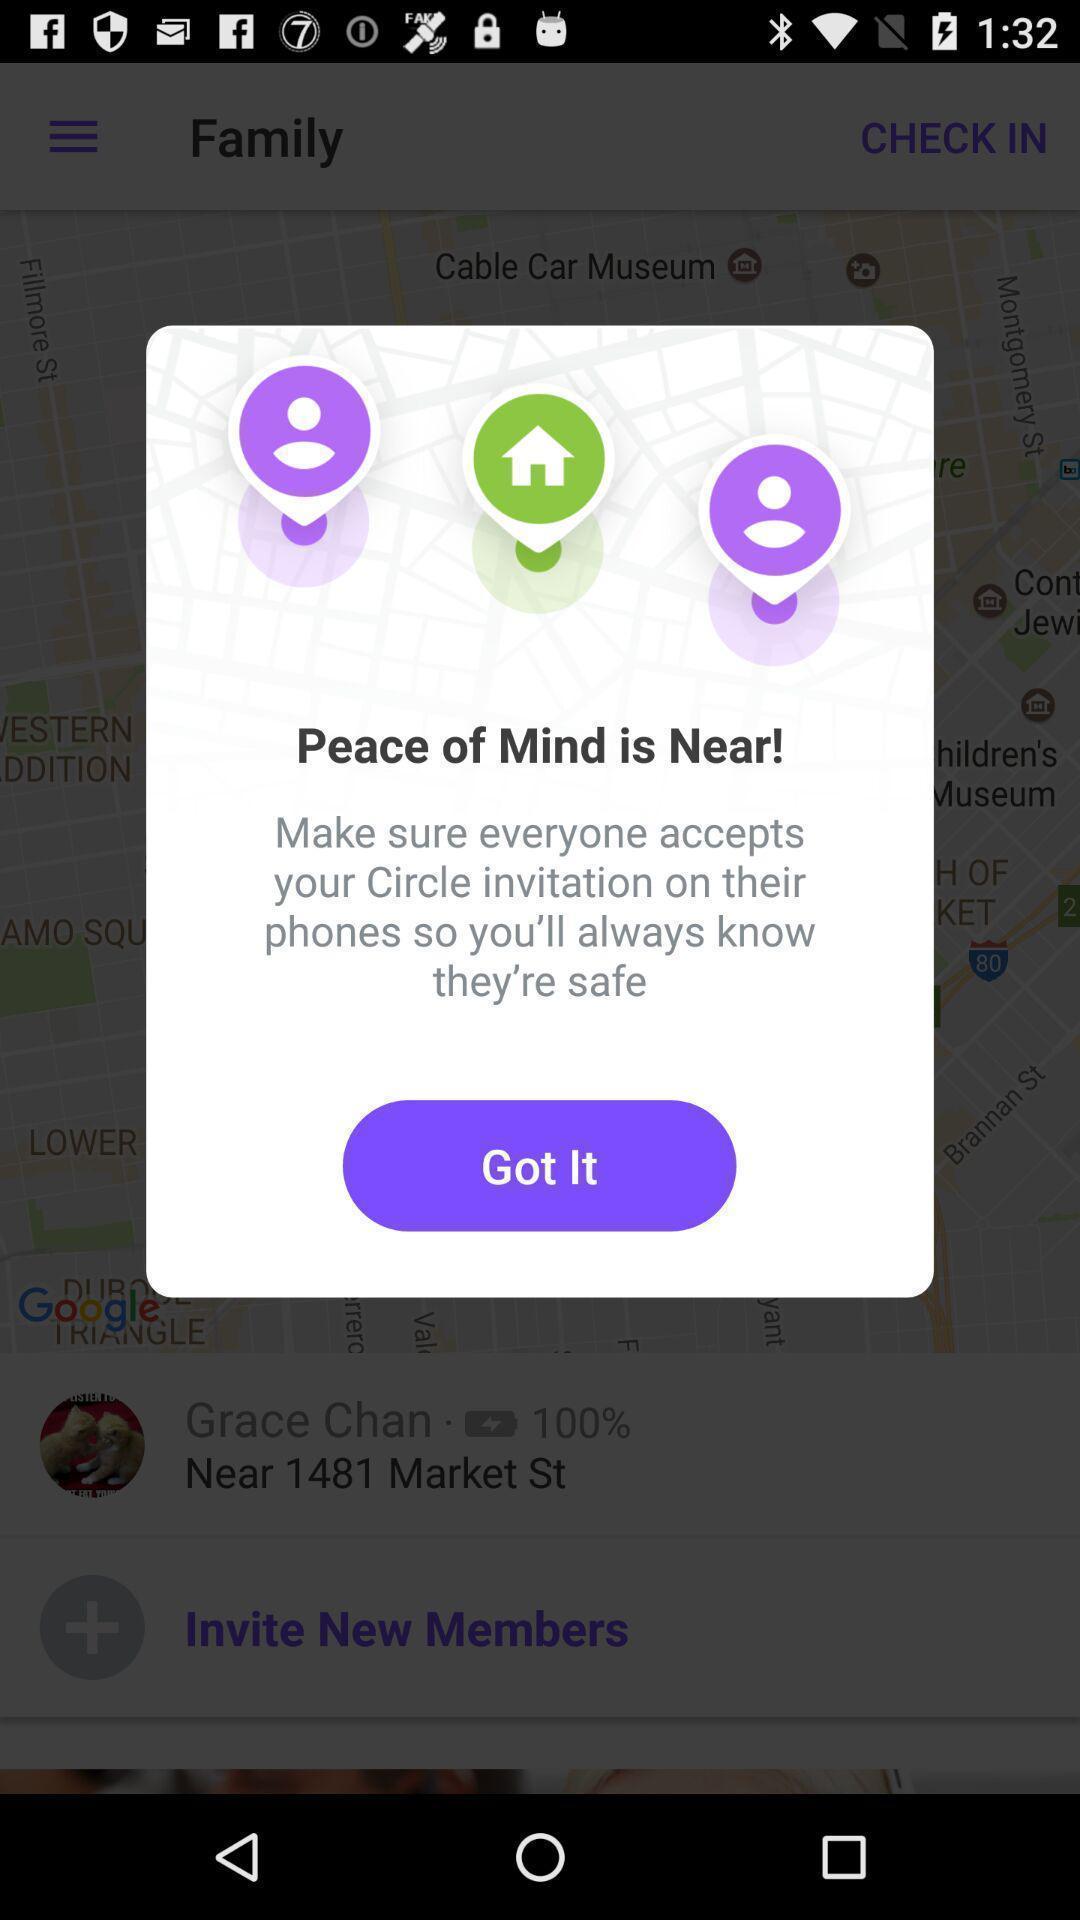Please provide a description for this image. Pop-up showing option like got it. 